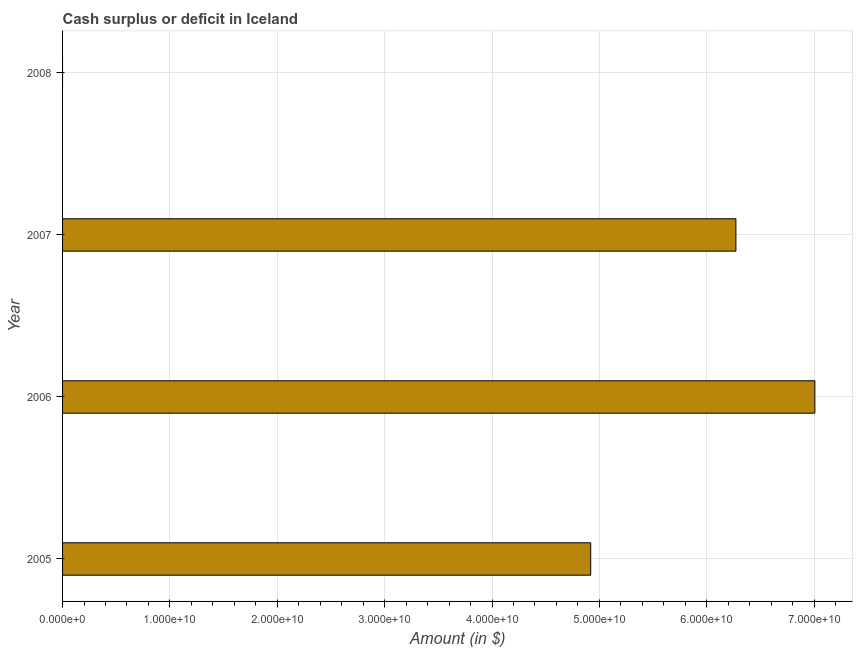Does the graph contain grids?
Keep it short and to the point. Yes. What is the title of the graph?
Give a very brief answer. Cash surplus or deficit in Iceland. What is the label or title of the X-axis?
Make the answer very short. Amount (in $). What is the cash surplus or deficit in 2005?
Your response must be concise. 4.92e+1. Across all years, what is the maximum cash surplus or deficit?
Your response must be concise. 7.01e+1. Across all years, what is the minimum cash surplus or deficit?
Make the answer very short. 0. What is the sum of the cash surplus or deficit?
Offer a terse response. 1.82e+11. What is the difference between the cash surplus or deficit in 2005 and 2006?
Ensure brevity in your answer.  -2.09e+1. What is the average cash surplus or deficit per year?
Offer a very short reply. 4.55e+1. What is the median cash surplus or deficit?
Make the answer very short. 5.60e+1. What is the ratio of the cash surplus or deficit in 2006 to that in 2007?
Your answer should be very brief. 1.12. Is the difference between the cash surplus or deficit in 2005 and 2007 greater than the difference between any two years?
Your answer should be very brief. No. What is the difference between the highest and the second highest cash surplus or deficit?
Provide a succinct answer. 7.36e+09. Is the sum of the cash surplus or deficit in 2005 and 2007 greater than the maximum cash surplus or deficit across all years?
Keep it short and to the point. Yes. What is the difference between the highest and the lowest cash surplus or deficit?
Your answer should be very brief. 7.01e+1. In how many years, is the cash surplus or deficit greater than the average cash surplus or deficit taken over all years?
Your response must be concise. 3. How many bars are there?
Offer a very short reply. 3. Are all the bars in the graph horizontal?
Your answer should be very brief. Yes. What is the Amount (in $) of 2005?
Give a very brief answer. 4.92e+1. What is the Amount (in $) in 2006?
Make the answer very short. 7.01e+1. What is the Amount (in $) of 2007?
Your answer should be compact. 6.27e+1. What is the Amount (in $) of 2008?
Keep it short and to the point. 0. What is the difference between the Amount (in $) in 2005 and 2006?
Your response must be concise. -2.09e+1. What is the difference between the Amount (in $) in 2005 and 2007?
Offer a very short reply. -1.35e+1. What is the difference between the Amount (in $) in 2006 and 2007?
Provide a short and direct response. 7.36e+09. What is the ratio of the Amount (in $) in 2005 to that in 2006?
Offer a very short reply. 0.7. What is the ratio of the Amount (in $) in 2005 to that in 2007?
Keep it short and to the point. 0.78. What is the ratio of the Amount (in $) in 2006 to that in 2007?
Offer a very short reply. 1.12. 